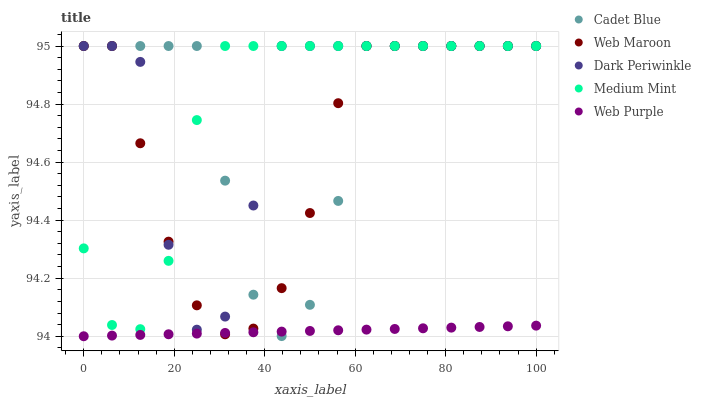Does Web Purple have the minimum area under the curve?
Answer yes or no. Yes. Does Dark Periwinkle have the maximum area under the curve?
Answer yes or no. Yes. Does Cadet Blue have the minimum area under the curve?
Answer yes or no. No. Does Cadet Blue have the maximum area under the curve?
Answer yes or no. No. Is Web Purple the smoothest?
Answer yes or no. Yes. Is Dark Periwinkle the roughest?
Answer yes or no. Yes. Is Cadet Blue the smoothest?
Answer yes or no. No. Is Cadet Blue the roughest?
Answer yes or no. No. Does Web Purple have the lowest value?
Answer yes or no. Yes. Does Cadet Blue have the lowest value?
Answer yes or no. No. Does Dark Periwinkle have the highest value?
Answer yes or no. Yes. Does Web Purple have the highest value?
Answer yes or no. No. Is Web Purple less than Medium Mint?
Answer yes or no. Yes. Is Medium Mint greater than Web Purple?
Answer yes or no. Yes. Does Web Purple intersect Web Maroon?
Answer yes or no. Yes. Is Web Purple less than Web Maroon?
Answer yes or no. No. Is Web Purple greater than Web Maroon?
Answer yes or no. No. Does Web Purple intersect Medium Mint?
Answer yes or no. No. 